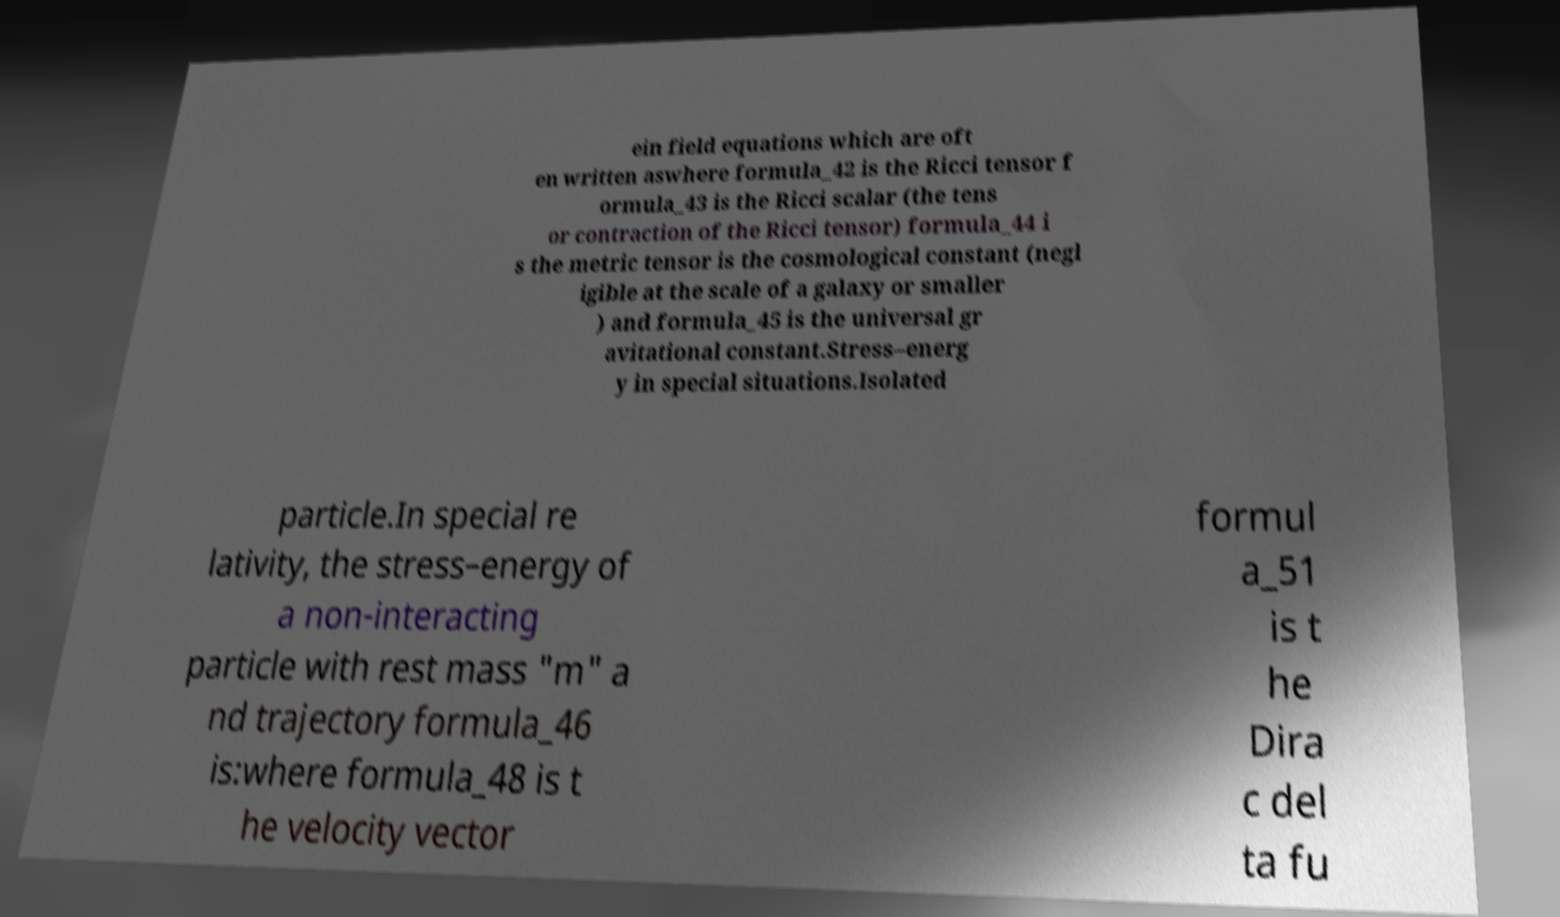Could you extract and type out the text from this image? ein field equations which are oft en written aswhere formula_42 is the Ricci tensor f ormula_43 is the Ricci scalar (the tens or contraction of the Ricci tensor) formula_44 i s the metric tensor is the cosmological constant (negl igible at the scale of a galaxy or smaller ) and formula_45 is the universal gr avitational constant.Stress–energ y in special situations.Isolated particle.In special re lativity, the stress–energy of a non-interacting particle with rest mass "m" a nd trajectory formula_46 is:where formula_48 is t he velocity vector formul a_51 is t he Dira c del ta fu 